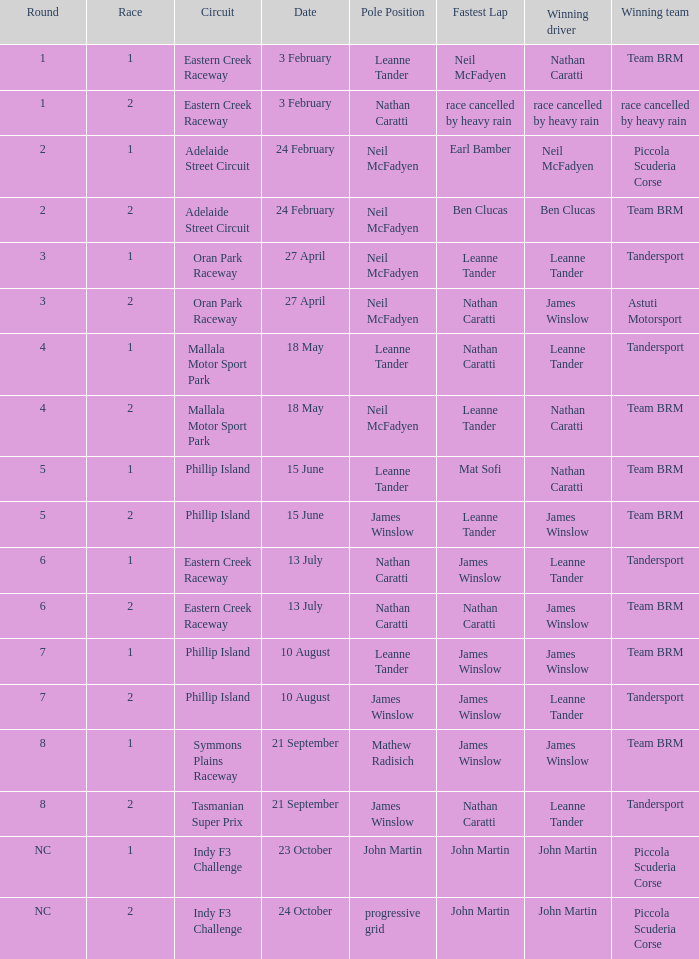Which race number in the indy f3 challenge course featured john martin in the leading position? 1.0. 